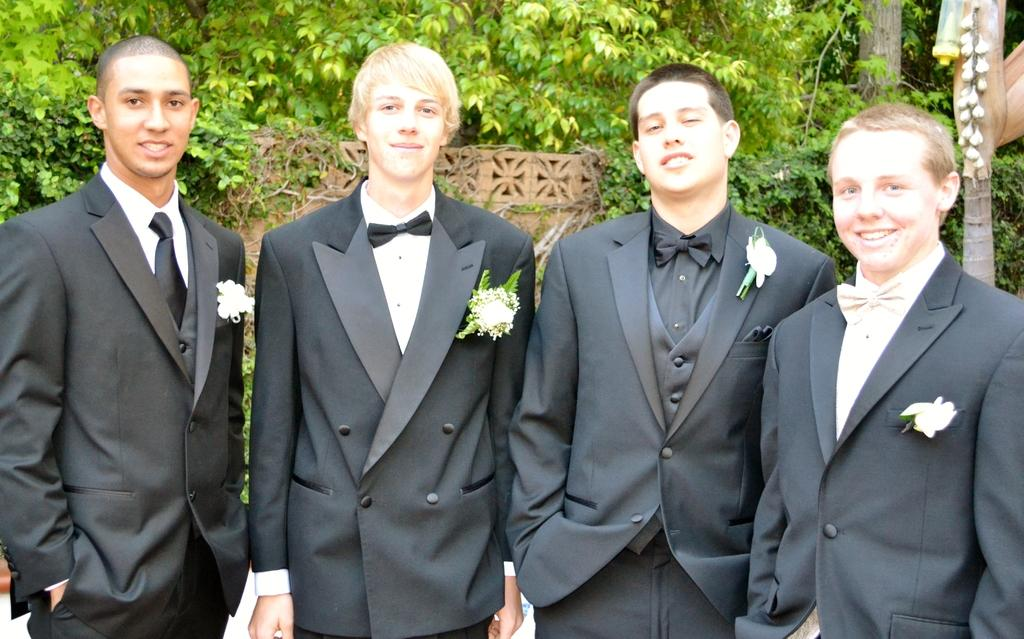How many people are present in the image? There are four men standing in the image. What can be seen in the background of the image? There are trees, plants, and a wall in the background of the image. Can you describe the object on the right side of the image? Unfortunately, the facts provided do not give any information about the object on the right side of the side of the image. What type of boot is the man wearing on his left foot? There is no information about boots or shoes in the image, so it is not possible to answer that question. 